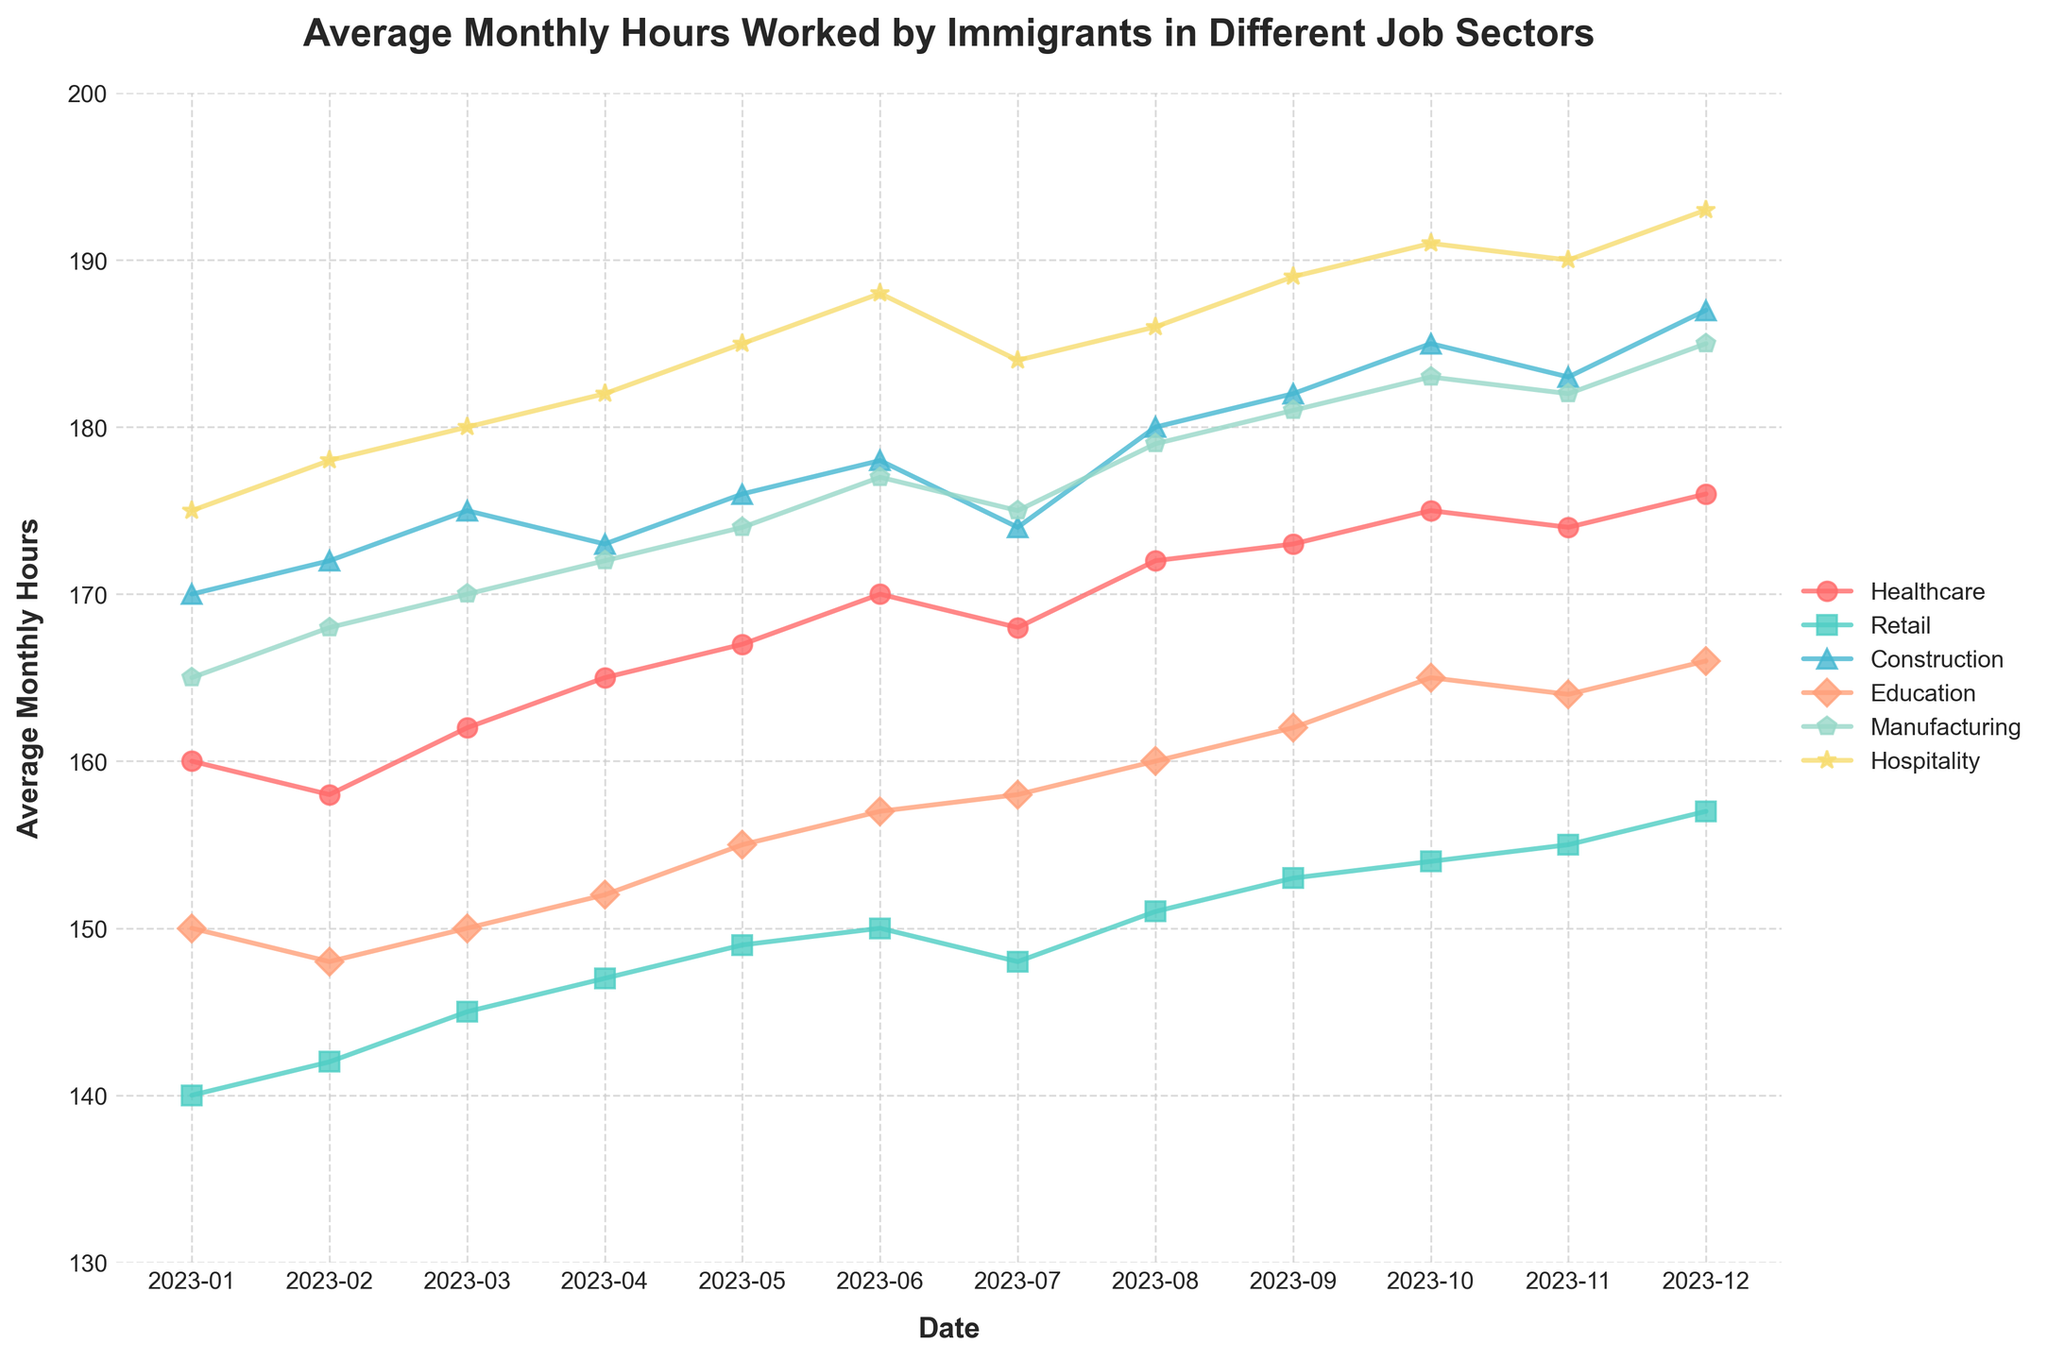Which job sector shows the highest average monthly hours worked in December 2023? First, look at the data points for December 2023 across all job sectors. The values are 176 (Healthcare), 157 (Retail), 187 (Construction), 166 (Education), 185 (Manufacturing), and 193 (Hospitality). The highest value is 193.
Answer: Hospitality Which month shows the peak average monthly hours for the Manufacturing sector? Examine the Manufacturing data points month by month. The peak value, 185, appears in December 2023.
Answer: December 2023 How do the average monthly hours worked by immigrants in the Retail sector change from January 2023 to December 2023? Compare the values for the Retail sector in January 2023 (140) and December 2023 (157). Subtract the starting value from the ending value: 157 - 140 = 17 hours.
Answer: Increase by 17 hours On average, which sector had the highest average monthly hours worked over the entire year? Add up all the values for each sector over the months, then divide each sum by 12 to find the annual average. Compare the results: 
Healthcare: (160+158+162+165+167+170+168+172+173+175+174+176)/12 = 168.08 
Retail: (140+142+145+147+149+150+148+151+153+154+155+157)/12 = 149.33 
Construction: (170+172+175+173+176+178+174+180+182+185+183+187)/12 = 177.25 
Education: (150+148+150+152+155+157+158+160+162+165+164+166)/12 = 157.67 
Manufacturing: (165+168+170+172+174+177+175+179+181+183+182+185)/12 = 174.75 
Hospitality: (175+178+180+182+185+188+184+186+189+191+190+193)/12 = 184.08
Hospitality has the highest annual average.
Answer: Hospitality Which job sector saw the smallest variation in the average monthly hours worked throughout the year? Calculate the range (maximum - minimum) for each sector:
Healthcare: 176 - 158 = 18 
Retail: 157 - 140 = 17 
Construction: 187 - 170 = 17 
Education: 166 - 148 = 18 
Manufacturing: 185 - 165 = 20 
Hospitality: 193 - 175 = 18 
Retail and Construction both have the smallest range of 17 hours.
Answer: Retail and Construction During which month do the average monthly hours worked for the Education sector surpass those of the Healthcare sector for the first time? Compare the monthly values of Education and Healthcare to find the first instance where Education surpasses Healthcare:
January 2023: Education (150) < Healthcare (160) 
February 2023: Education (148) < Healthcare (158) 
March 2023: Education (150) < Healthcare (162) 
April 2023: Education (152) < Healthcare (165) 
May 2023: Education (155) < Healthcare (167) 
June 2023: Education (157) < Healthcare (170) 
July 2023: Education (158) < Healthcare (168) 
August 2023: Education (160) < Healthcare (172) 
September 2023: Education (162) < Healthcare (173) 
October 2023: Education (165) < Healthcare (175) 
November 2023: Education (164) < Healthcare (174) 
December 2023: Education (166) < Healthcare (176)
There is no month when the Education sector surpasses Healthcare.
Answer: Never What is the total number of hours worked by immigrants in the Hospitality sector over the year 2023? Sum up all the monthly values for Hospitality: 
175 + 178 + 180 + 182 + 185 + 188 + 184 + 186 + 189 + 191 + 190 + 193 = 2221 hours.
Answer: 2221 hours Compare the change in average monthly hours from January to December for Healthcare and Retail. Which sector had a larger increase? Calculate the difference between December and January values for each sector:
Healthcare: 176 - 160 = 16 
Retail: 157 - 140 = 17 
Retail had a larger increase of 17 hours compared to Healthcare's 16 hours.
Answer: Retail What is the month with the lowest average monthly hours worked in the Construction sector? Check the monthly values for Construction and identify the lowest value: 
170 (January), 172 (February), 175 (March), 173 (April), 176 (May), 178 (June), 174 (July), 180 (August), 182 (September), 185 (October), 183 (November), 187 (December). The lowest value is 170 in January 2023.
Answer: January 2023 